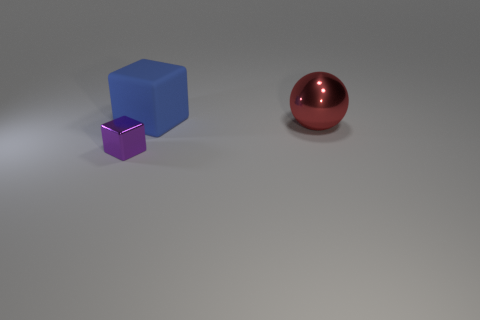Subtract all purple blocks. How many blocks are left? 1 Add 3 large metallic objects. How many objects exist? 6 Subtract all balls. How many objects are left? 2 Subtract 1 cubes. How many cubes are left? 1 Subtract 1 red balls. How many objects are left? 2 Subtract all green blocks. Subtract all yellow balls. How many blocks are left? 2 Subtract all big blue matte objects. Subtract all small purple metallic objects. How many objects are left? 1 Add 2 big red metallic balls. How many big red metallic balls are left? 3 Add 3 shiny blocks. How many shiny blocks exist? 4 